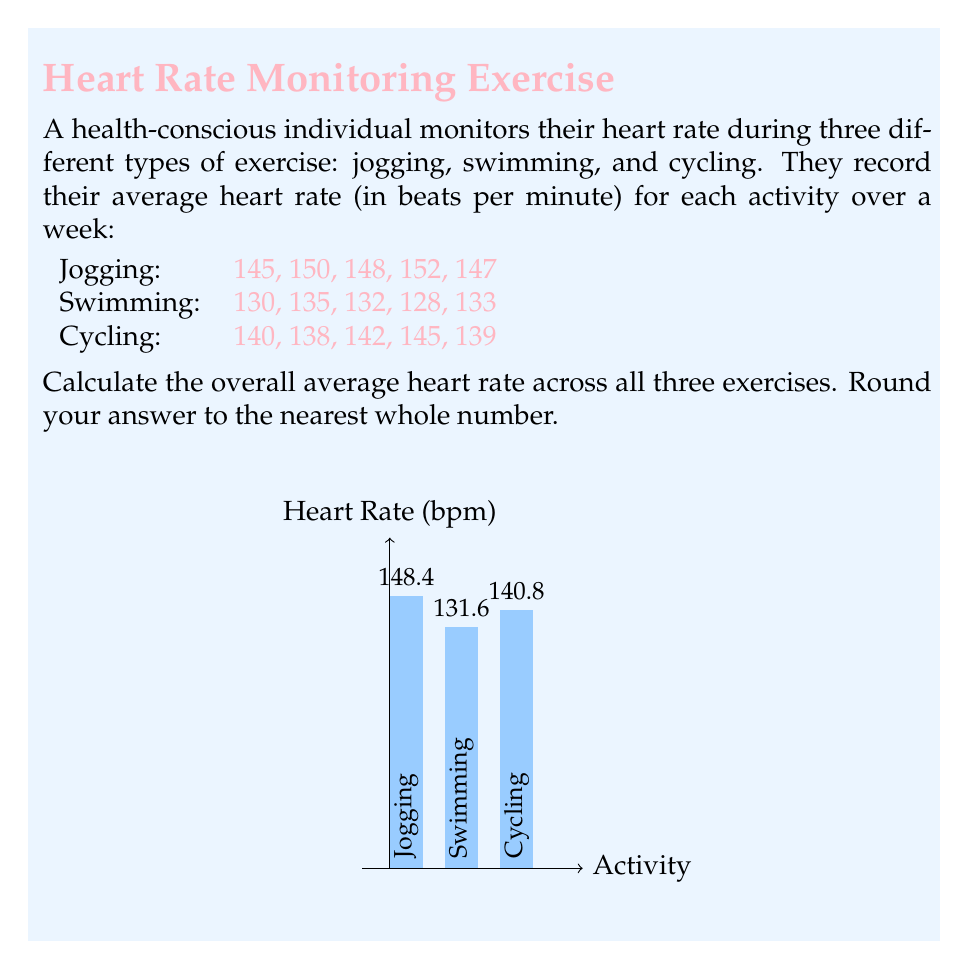What is the answer to this math problem? To solve this problem, we'll follow these steps:

1) First, calculate the average heart rate for each activity:

   Jogging: $\frac{145 + 150 + 148 + 152 + 147}{5} = \frac{742}{5} = 148.4$ bpm
   Swimming: $\frac{130 + 135 + 132 + 128 + 133}{5} = \frac{658}{5} = 131.6$ bpm
   Cycling: $\frac{140 + 138 + 142 + 145 + 139}{5} = \frac{704}{5} = 140.8$ bpm

2) Now, to find the overall average, we need to sum these averages and divide by the number of activities:

   $$\text{Overall Average} = \frac{148.4 + 131.6 + 140.8}{3}$$

3) Let's perform this calculation:

   $$\frac{148.4 + 131.6 + 140.8}{3} = \frac{420.8}{3} = 140.2666...$$

4) Rounding to the nearest whole number:

   140.2666... rounds to 140 bpm

Therefore, the overall average heart rate across all three exercises, rounded to the nearest whole number, is 140 bpm.
Answer: 140 bpm 